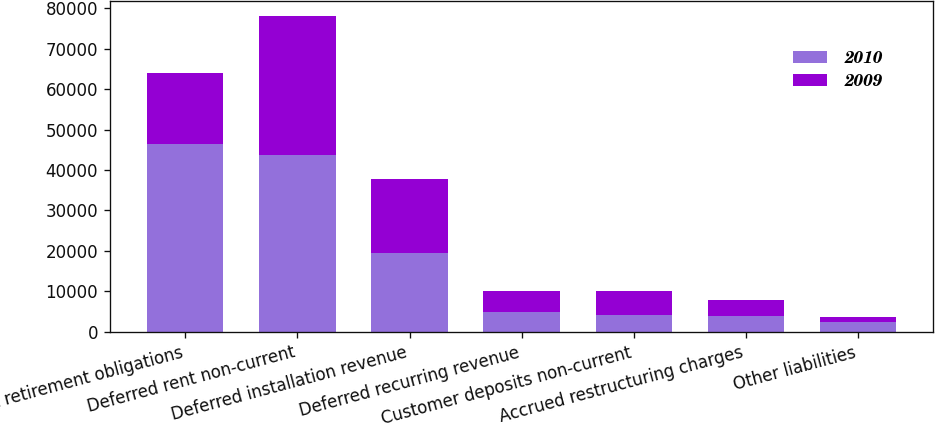Convert chart to OTSL. <chart><loc_0><loc_0><loc_500><loc_500><stacked_bar_chart><ecel><fcel>Asset retirement obligations<fcel>Deferred rent non-current<fcel>Deferred installation revenue<fcel>Deferred recurring revenue<fcel>Customer deposits non-current<fcel>Accrued restructuring charges<fcel>Other liabilities<nl><fcel>2010<fcel>46322<fcel>43705<fcel>19488<fcel>4897<fcel>4206<fcel>3952<fcel>2473<nl><fcel>2009<fcel>17710<fcel>34288<fcel>18228<fcel>5160<fcel>5813<fcel>3876<fcel>1095<nl></chart> 